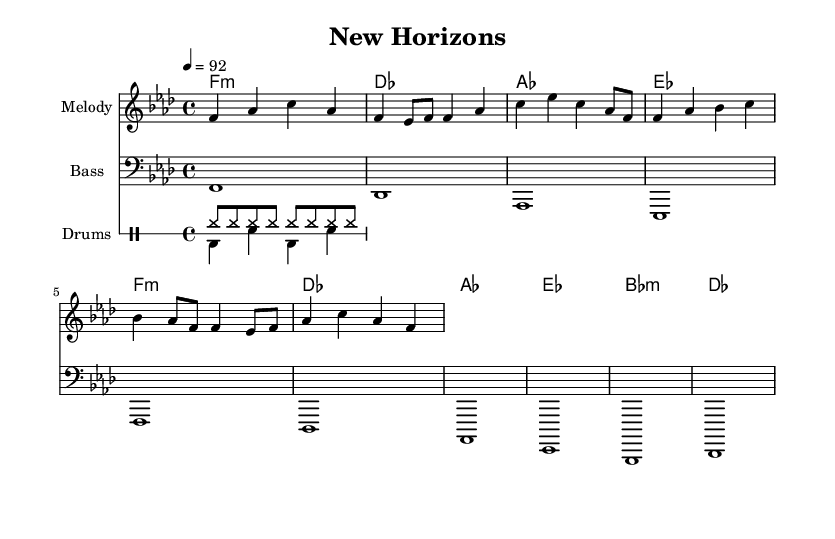What is the key signature of this music? The key signature is F minor, which has four flats: B flat, E flat, A flat, and D flat. This can be deduced from the key signature indicated at the beginning of the music.
Answer: F minor What is the time signature of this music? The time signature is 4/4, shown at the beginning of the sheet music. It indicates that there are four beats in each measure and the quarter note gets one beat.
Answer: 4/4 What is the tempo marking for this piece? The tempo marking is a quarter note equal to 92 beats per minute, indicated by the tempo notation in the score. This informs the performer about the speed of the music.
Answer: 92 How many measures are in the melody? The melody consists of 8 measures, as there are eight groupings of notes separated by vertical lines, which indicate the end of each measure in the score.
Answer: 8 What instrument is indicated for the melody? The melody is indicated for a staff labeled "Melody," which typically signifies it is for a piano or another melodic instrument, but it is primarily showcasing the lead vocal line here.
Answer: Melody What is the structure of the harmony chords? The harmony consists of alternating chords built around F minor, specifically F minor, D flat, A flat, and E flat, which are common in both pop and hip-hop music. This creates a progression that supports the melody effectively.
Answer: F minor, D flat, A flat, E flat 